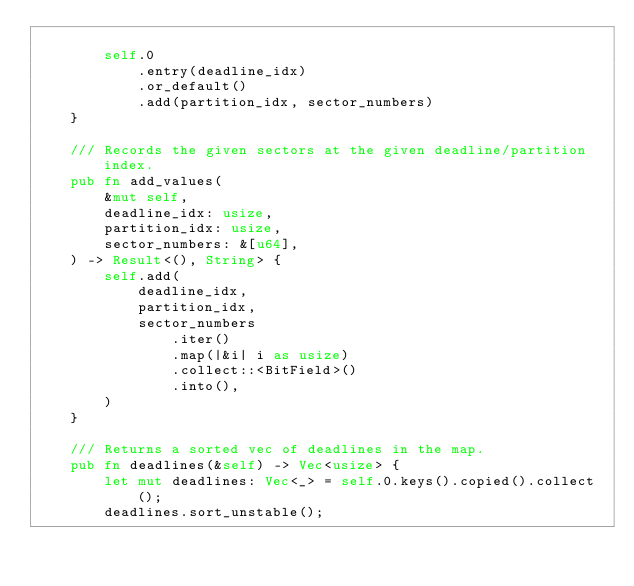<code> <loc_0><loc_0><loc_500><loc_500><_Rust_>
        self.0
            .entry(deadline_idx)
            .or_default()
            .add(partition_idx, sector_numbers)
    }

    /// Records the given sectors at the given deadline/partition index.
    pub fn add_values(
        &mut self,
        deadline_idx: usize,
        partition_idx: usize,
        sector_numbers: &[u64],
    ) -> Result<(), String> {
        self.add(
            deadline_idx,
            partition_idx,
            sector_numbers
                .iter()
                .map(|&i| i as usize)
                .collect::<BitField>()
                .into(),
        )
    }

    /// Returns a sorted vec of deadlines in the map.
    pub fn deadlines(&self) -> Vec<usize> {
        let mut deadlines: Vec<_> = self.0.keys().copied().collect();
        deadlines.sort_unstable();</code> 